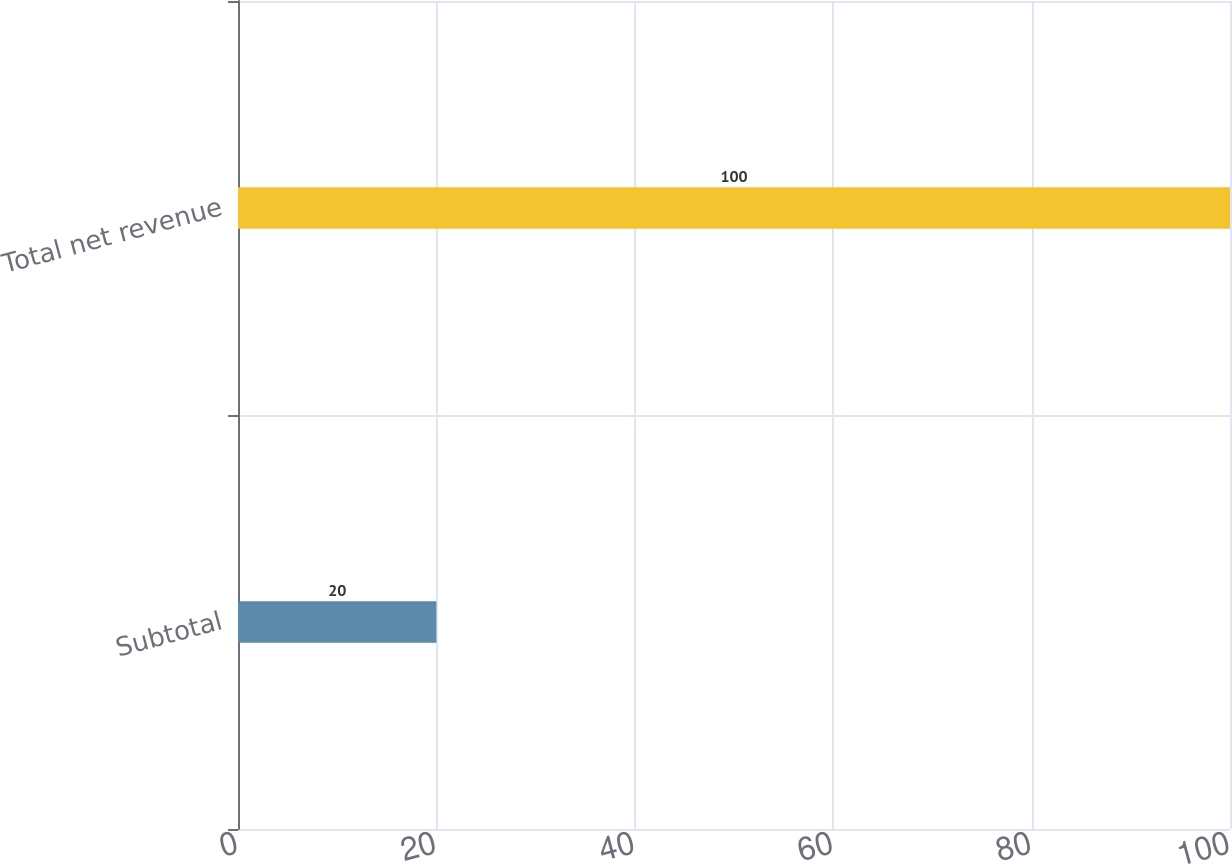Convert chart to OTSL. <chart><loc_0><loc_0><loc_500><loc_500><bar_chart><fcel>Subtotal<fcel>Total net revenue<nl><fcel>20<fcel>100<nl></chart> 